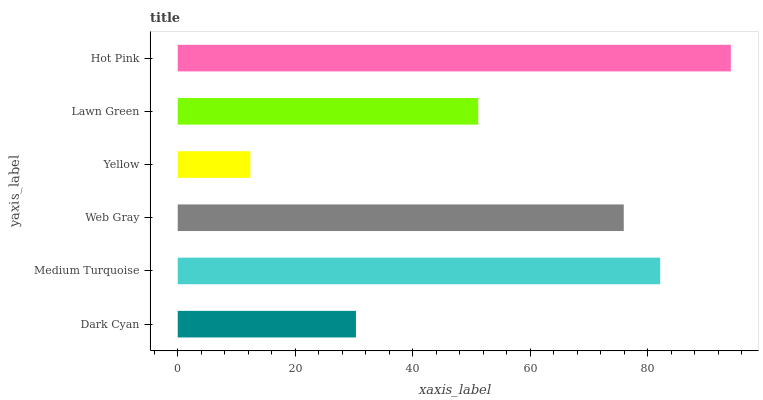Is Yellow the minimum?
Answer yes or no. Yes. Is Hot Pink the maximum?
Answer yes or no. Yes. Is Medium Turquoise the minimum?
Answer yes or no. No. Is Medium Turquoise the maximum?
Answer yes or no. No. Is Medium Turquoise greater than Dark Cyan?
Answer yes or no. Yes. Is Dark Cyan less than Medium Turquoise?
Answer yes or no. Yes. Is Dark Cyan greater than Medium Turquoise?
Answer yes or no. No. Is Medium Turquoise less than Dark Cyan?
Answer yes or no. No. Is Web Gray the high median?
Answer yes or no. Yes. Is Lawn Green the low median?
Answer yes or no. Yes. Is Hot Pink the high median?
Answer yes or no. No. Is Hot Pink the low median?
Answer yes or no. No. 